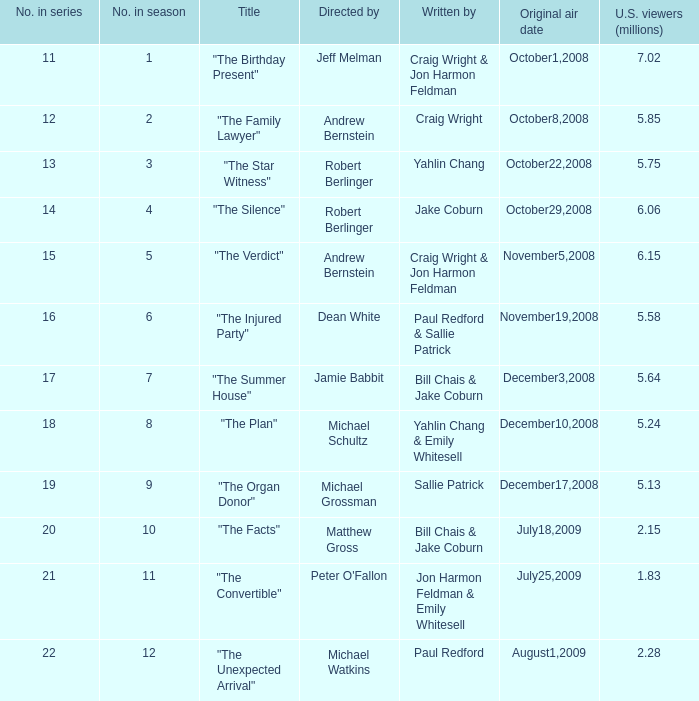What is the premiere air date of the episode directed by jeff melman? October1,2008. 